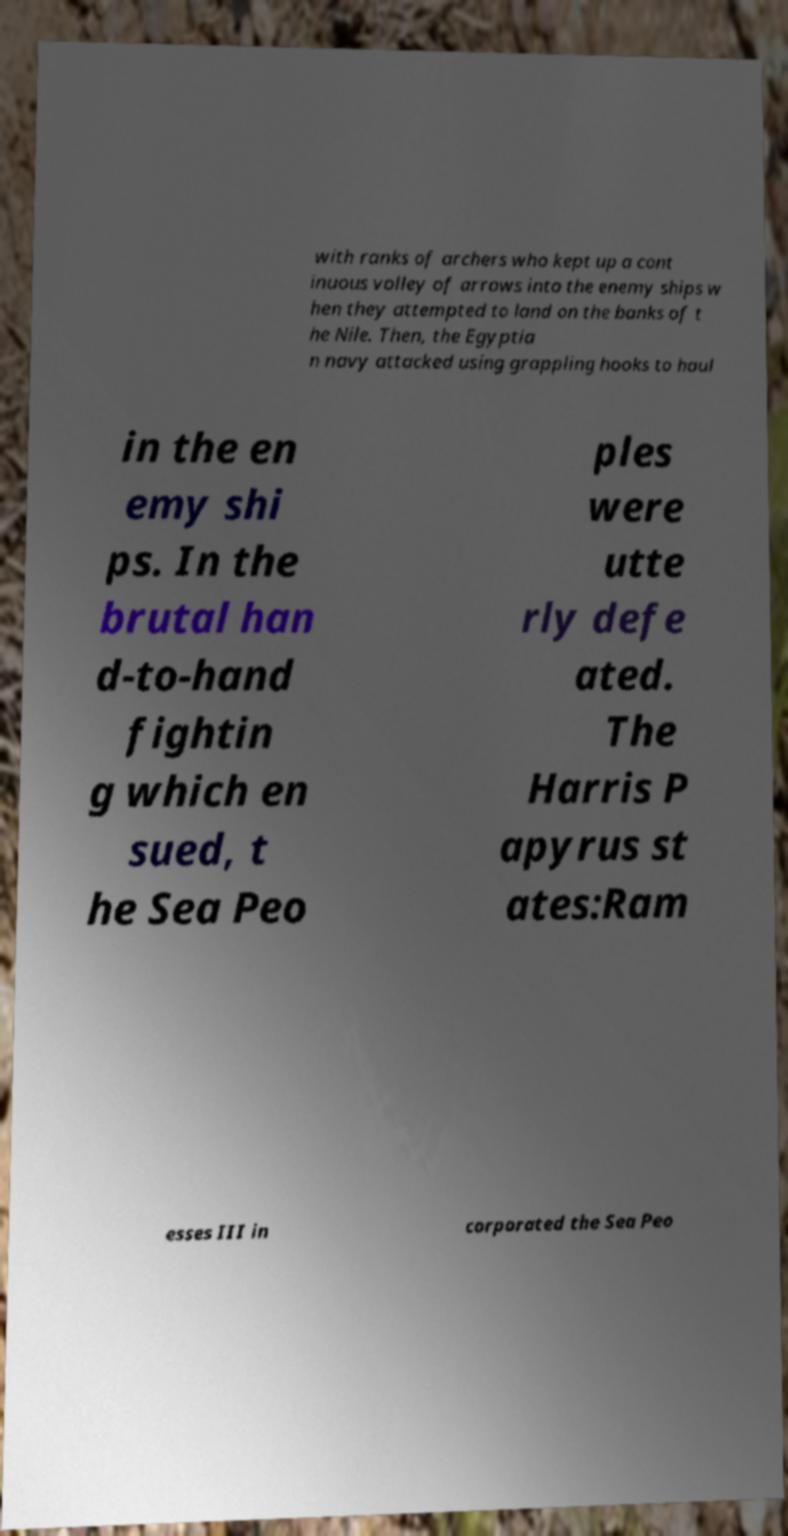What messages or text are displayed in this image? I need them in a readable, typed format. with ranks of archers who kept up a cont inuous volley of arrows into the enemy ships w hen they attempted to land on the banks of t he Nile. Then, the Egyptia n navy attacked using grappling hooks to haul in the en emy shi ps. In the brutal han d-to-hand fightin g which en sued, t he Sea Peo ples were utte rly defe ated. The Harris P apyrus st ates:Ram esses III in corporated the Sea Peo 